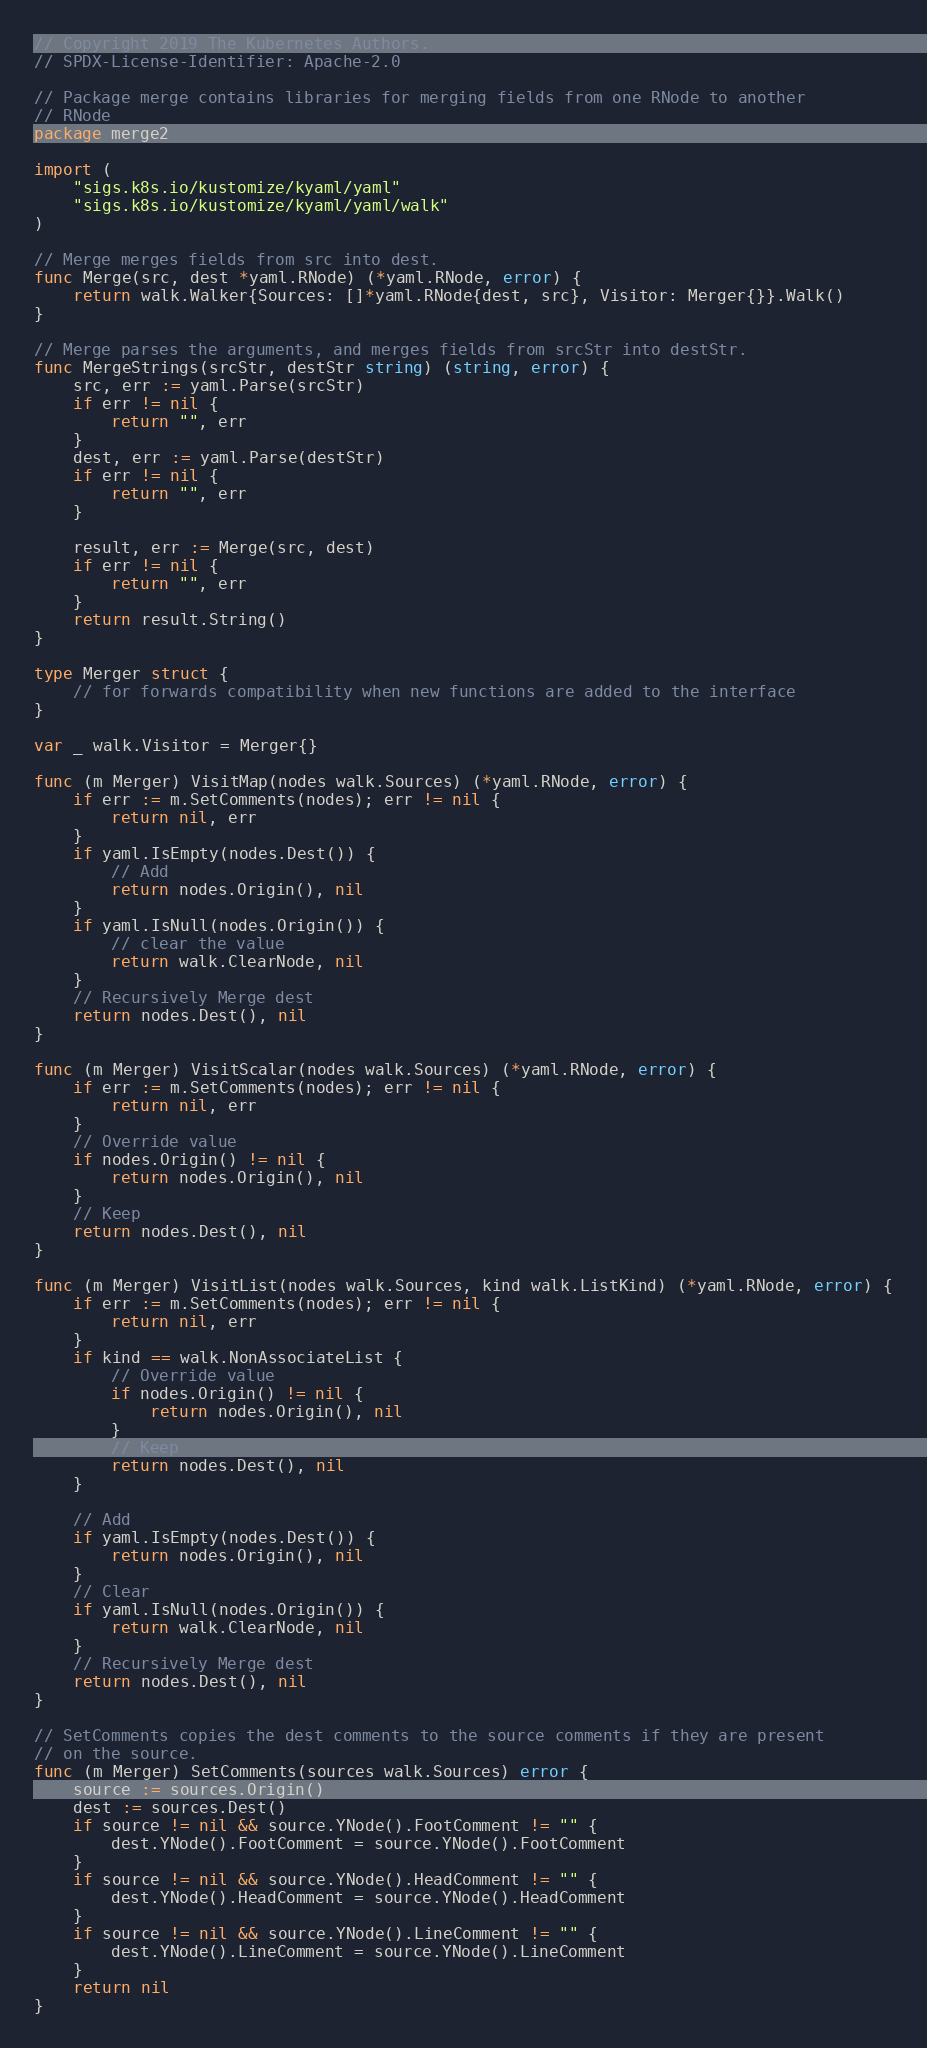Convert code to text. <code><loc_0><loc_0><loc_500><loc_500><_Go_>// Copyright 2019 The Kubernetes Authors.
// SPDX-License-Identifier: Apache-2.0

// Package merge contains libraries for merging fields from one RNode to another
// RNode
package merge2

import (
	"sigs.k8s.io/kustomize/kyaml/yaml"
	"sigs.k8s.io/kustomize/kyaml/yaml/walk"
)

// Merge merges fields from src into dest.
func Merge(src, dest *yaml.RNode) (*yaml.RNode, error) {
	return walk.Walker{Sources: []*yaml.RNode{dest, src}, Visitor: Merger{}}.Walk()
}

// Merge parses the arguments, and merges fields from srcStr into destStr.
func MergeStrings(srcStr, destStr string) (string, error) {
	src, err := yaml.Parse(srcStr)
	if err != nil {
		return "", err
	}
	dest, err := yaml.Parse(destStr)
	if err != nil {
		return "", err
	}

	result, err := Merge(src, dest)
	if err != nil {
		return "", err
	}
	return result.String()
}

type Merger struct {
	// for forwards compatibility when new functions are added to the interface
}

var _ walk.Visitor = Merger{}

func (m Merger) VisitMap(nodes walk.Sources) (*yaml.RNode, error) {
	if err := m.SetComments(nodes); err != nil {
		return nil, err
	}
	if yaml.IsEmpty(nodes.Dest()) {
		// Add
		return nodes.Origin(), nil
	}
	if yaml.IsNull(nodes.Origin()) {
		// clear the value
		return walk.ClearNode, nil
	}
	// Recursively Merge dest
	return nodes.Dest(), nil
}

func (m Merger) VisitScalar(nodes walk.Sources) (*yaml.RNode, error) {
	if err := m.SetComments(nodes); err != nil {
		return nil, err
	}
	// Override value
	if nodes.Origin() != nil {
		return nodes.Origin(), nil
	}
	// Keep
	return nodes.Dest(), nil
}

func (m Merger) VisitList(nodes walk.Sources, kind walk.ListKind) (*yaml.RNode, error) {
	if err := m.SetComments(nodes); err != nil {
		return nil, err
	}
	if kind == walk.NonAssociateList {
		// Override value
		if nodes.Origin() != nil {
			return nodes.Origin(), nil
		}
		// Keep
		return nodes.Dest(), nil
	}

	// Add
	if yaml.IsEmpty(nodes.Dest()) {
		return nodes.Origin(), nil
	}
	// Clear
	if yaml.IsNull(nodes.Origin()) {
		return walk.ClearNode, nil
	}
	// Recursively Merge dest
	return nodes.Dest(), nil
}

// SetComments copies the dest comments to the source comments if they are present
// on the source.
func (m Merger) SetComments(sources walk.Sources) error {
	source := sources.Origin()
	dest := sources.Dest()
	if source != nil && source.YNode().FootComment != "" {
		dest.YNode().FootComment = source.YNode().FootComment
	}
	if source != nil && source.YNode().HeadComment != "" {
		dest.YNode().HeadComment = source.YNode().HeadComment
	}
	if source != nil && source.YNode().LineComment != "" {
		dest.YNode().LineComment = source.YNode().LineComment
	}
	return nil
}
</code> 